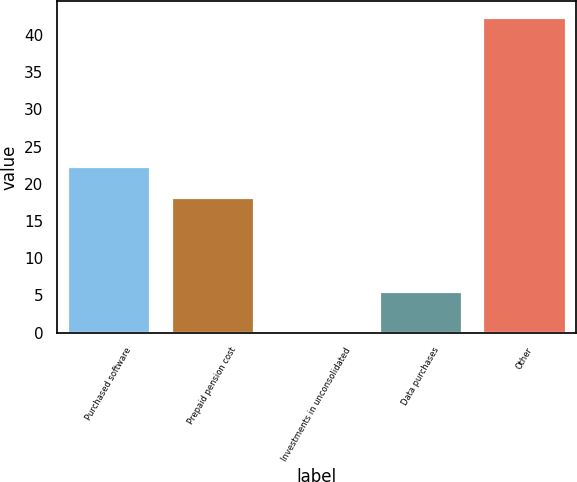<chart> <loc_0><loc_0><loc_500><loc_500><bar_chart><fcel>Purchased software<fcel>Prepaid pension cost<fcel>Investments in unconsolidated<fcel>Data purchases<fcel>Other<nl><fcel>22.4<fcel>18.2<fcel>0.4<fcel>5.6<fcel>42.4<nl></chart> 